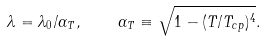<formula> <loc_0><loc_0><loc_500><loc_500>\lambda = \lambda _ { 0 } / \alpha _ { T } , \quad \alpha _ { T } \equiv \sqrt { 1 - ( T / T _ { c p } ) ^ { 4 } } .</formula> 